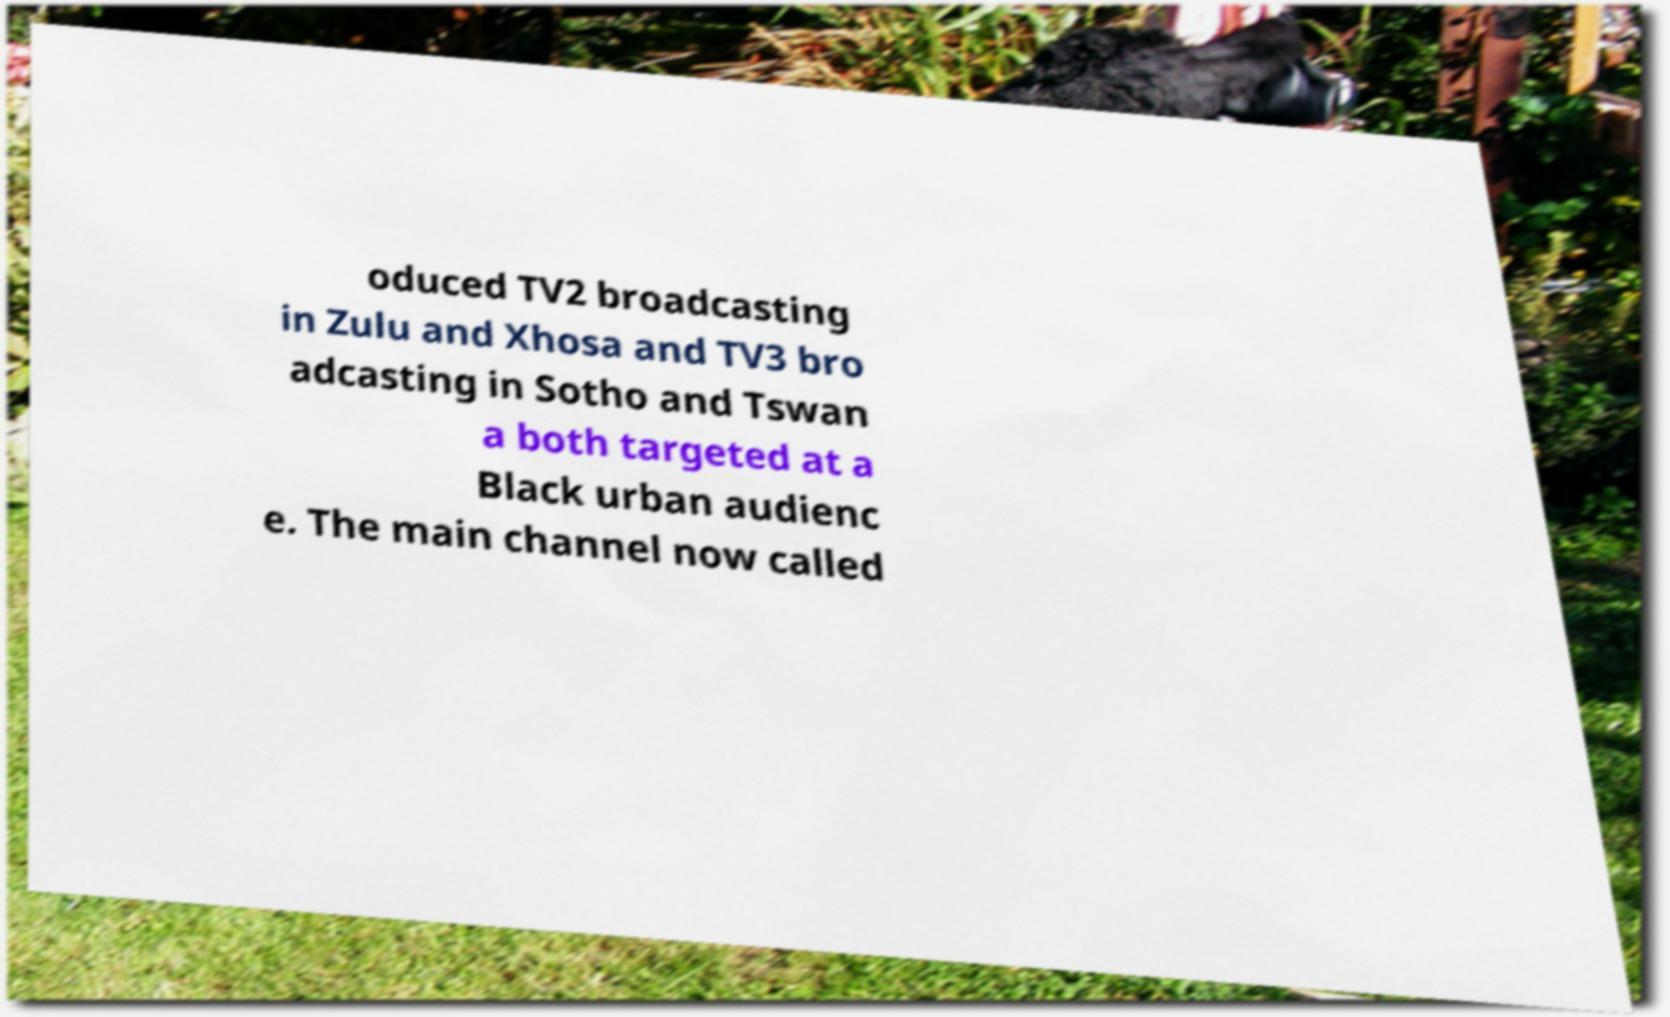What messages or text are displayed in this image? I need them in a readable, typed format. oduced TV2 broadcasting in Zulu and Xhosa and TV3 bro adcasting in Sotho and Tswan a both targeted at a Black urban audienc e. The main channel now called 